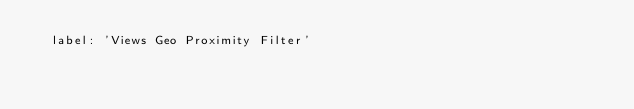<code> <loc_0><loc_0><loc_500><loc_500><_YAML_>  label: 'Views Geo Proximity Filter'
</code> 